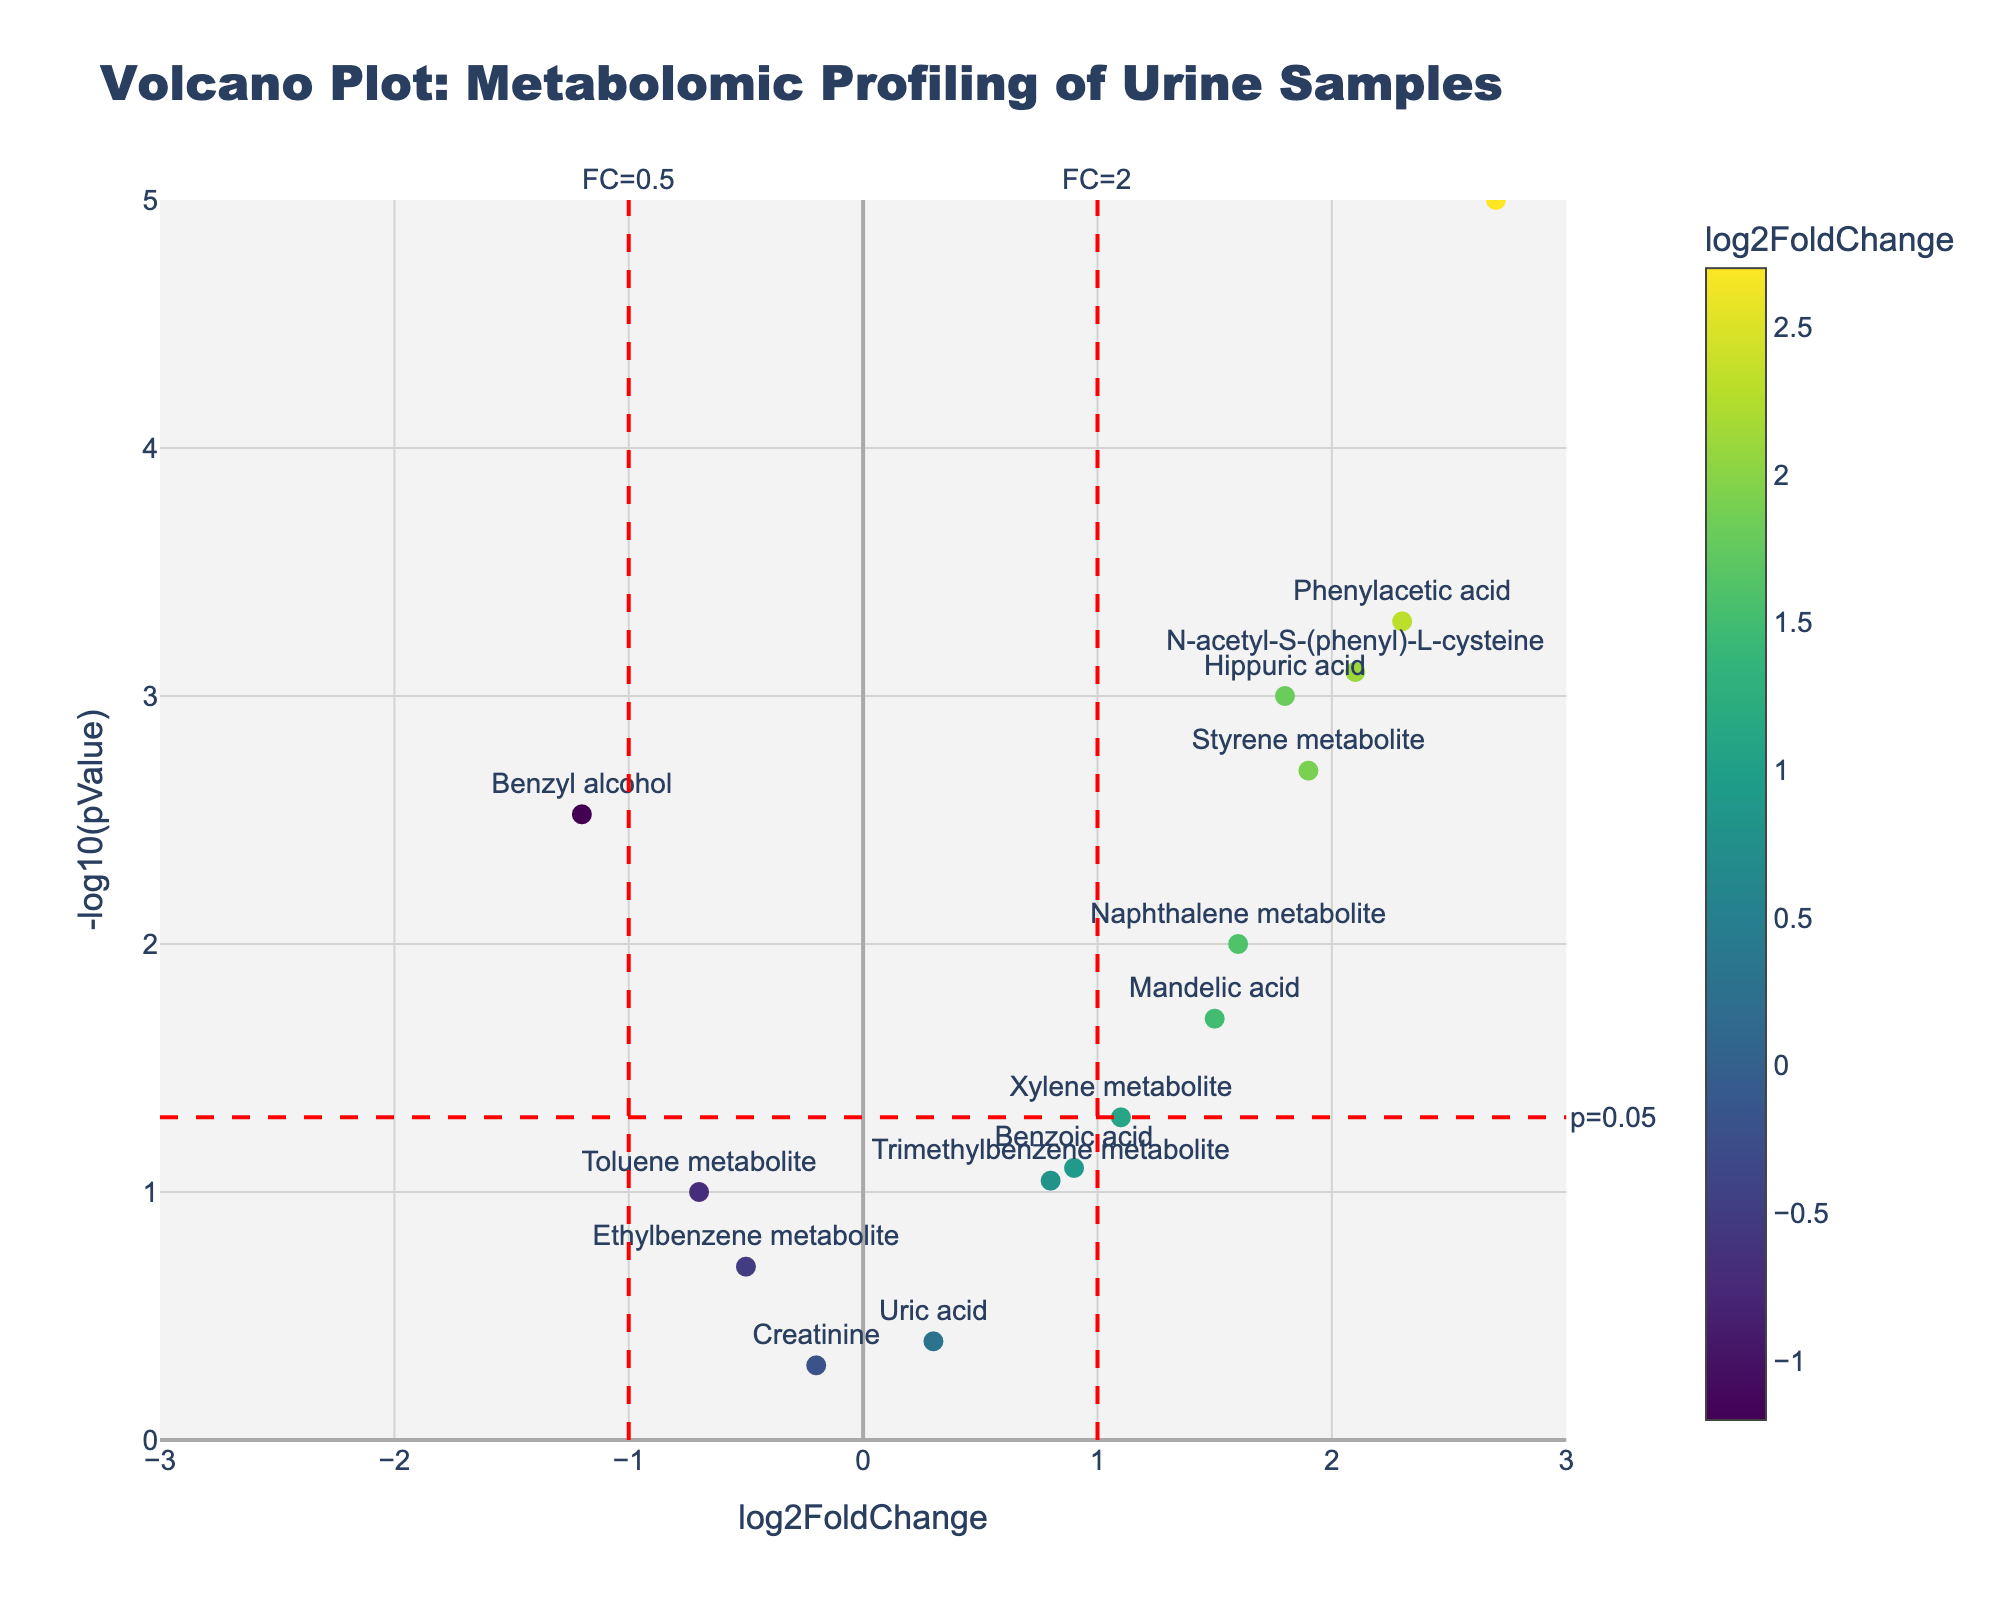What is the title of the figure? The title is usually located at the top of a figure and often describes what the figure is about. In this case, you find it says "Volcano Plot: Metabolomic Profiling of Urine Samples."
Answer: Volcano Plot: Metabolomic Profiling of Urine Samples Which metabolite has the highest -log10(pValue)? You need to look at the y-axis, which represents -log10(pValue), and find the highest point. The highest point is for "Phenylglyoxylic acid."
Answer: Phenylglyoxylic acid Which metabolites have a log2FoldChange greater than 1 and a p-value less than 0.05? Identify points with log2FoldChange > 1 and -log10(pValue) > -log10(0.05). These metabolites are "Phenylacetic acid," "Phenylglyoxylic acid," "N-acetyl-S-(phenyl)-L-cysteine," and "Styrene metabolite."
Answer: Phenylacetic acid, Phenylglyoxylic acid, N-acetyl-S-(phenyl)-L-cysteine, Styrene metabolite How many metabolites have a p-value less than 0.05? To determine this, find the number of points above the red dashed line at -log10(0.05). There are six such metabolites.
Answer: 6 What is the log2FoldChange and p-value for "Benzyl alcohol"? Locate the point labeled "Benzyl alcohol" and read its coordinate values. The log2FoldChange is -1.2 and the p-value is 0.003.
Answer: log2FoldChange: -1.2, p-value: 0.003 Which metabolite is closest to the origin (0,0) on the plot? Check the coordinates for each metabolite and find the one with the smallest difference from (0,0). "Creatinine" is closest to the origin.
Answer: Creatinine Does any metabolite have a log2FoldChange between -1 and 1 and a significant p-value (<0.05)? Check points within the range -1 < log2FoldChange < 1 that are above the red dashed line at -log10(0.05). "Xylene metabolite" is the only one fitting this criterion.
Answer: Xylene metabolite What color represents the metabolite with the highest fold change? The color scale indicates higher log2FoldChange values with a specific color. "Phenylglyoxylic acid" has the highest log2FoldChange represented by the color corresponding to the highest value on the Viridis scale.
Answer: Viridis scale color for highest value Which metabolite has the smallest absolute log2FoldChange? Look for the point closest to the y-axis (log2FoldChange = 0). "Creatinine" has the smallest absolute log2FoldChange.
Answer: Creatinine 